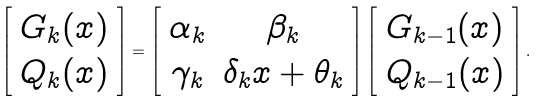Convert formula to latex. <formula><loc_0><loc_0><loc_500><loc_500>\left [ \begin{array} { c } G _ { k } ( x ) \\ Q _ { k } ( x ) \end{array} \right ] = \left [ \begin{array} { c c } \alpha _ { k } & \beta _ { k } \\ \gamma _ { k } & \delta _ { k } x + \theta _ { k } \end{array} \right ] \left [ \begin{array} { c } G _ { k - 1 } ( x ) \\ Q _ { k - 1 } ( x ) \end{array} \right ] .</formula> 